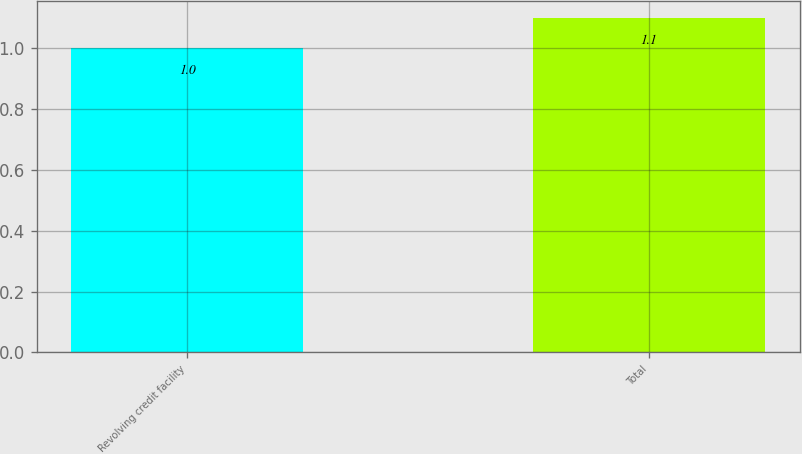Convert chart to OTSL. <chart><loc_0><loc_0><loc_500><loc_500><bar_chart><fcel>Revolving credit facility<fcel>Total<nl><fcel>1<fcel>1.1<nl></chart> 